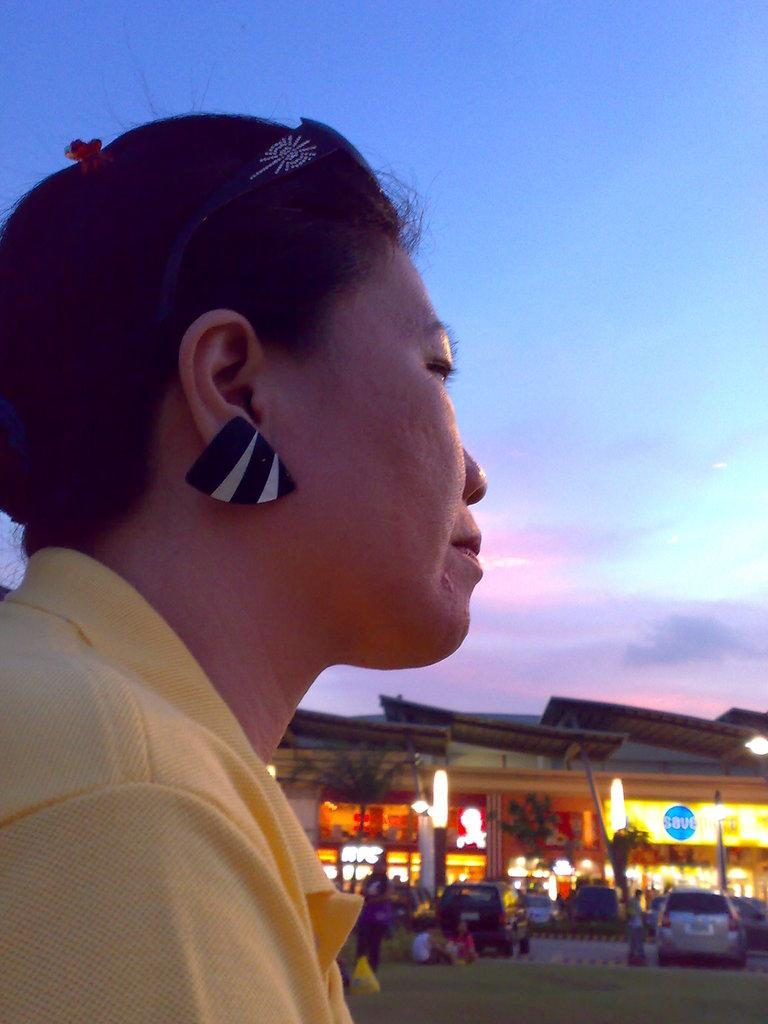Who is present in the image? There is a woman in the image. What else can be seen in the image besides the woman? There are vehicles, a building, a tree, and the sky visible in the image. What type of rock can be seen in the image? There is no rock present in the image. Is there an alley visible in the image? There is no alley present in the image. 